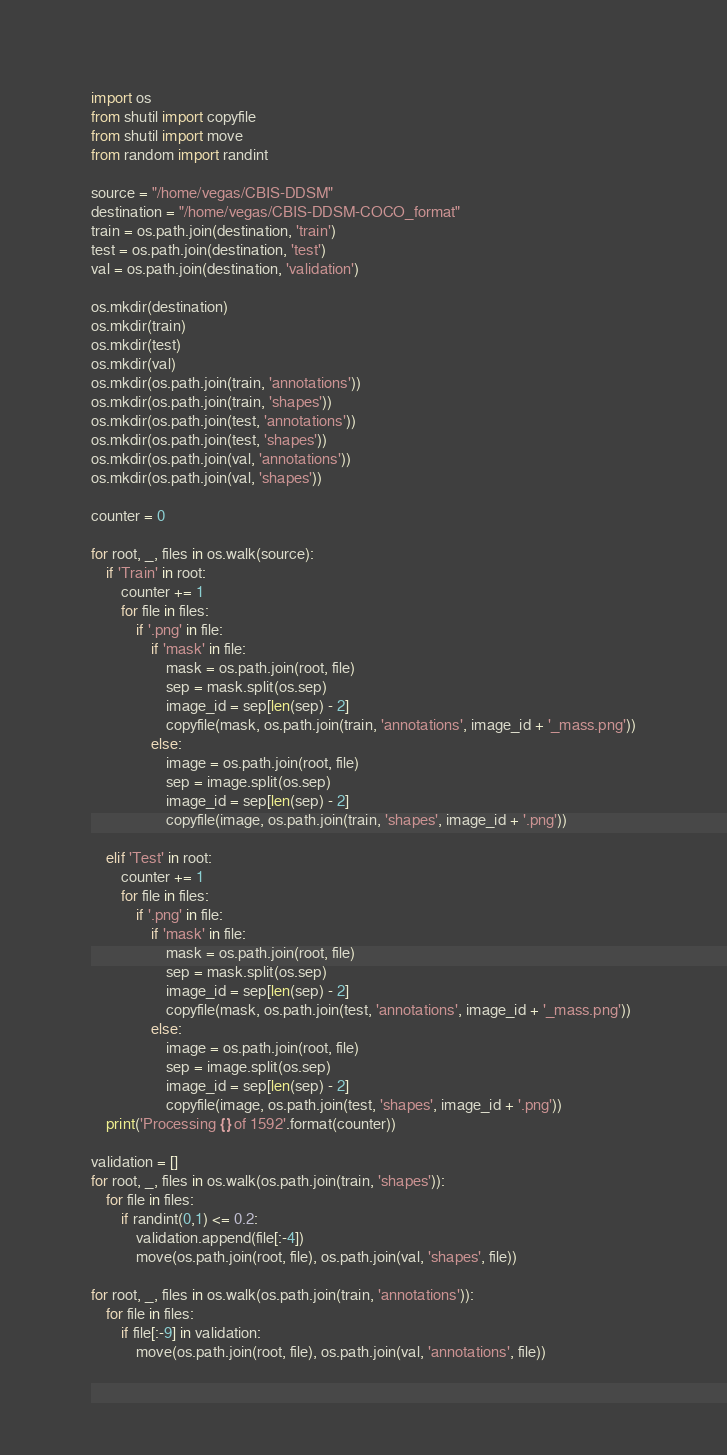<code> <loc_0><loc_0><loc_500><loc_500><_Python_>import os
from shutil import copyfile
from shutil import move
from random import randint

source = "/home/vegas/CBIS-DDSM"
destination = "/home/vegas/CBIS-DDSM-COCO_format"
train = os.path.join(destination, 'train')
test = os.path.join(destination, 'test')
val = os.path.join(destination, 'validation')

os.mkdir(destination)
os.mkdir(train)
os.mkdir(test)
os.mkdir(val)
os.mkdir(os.path.join(train, 'annotations'))
os.mkdir(os.path.join(train, 'shapes'))
os.mkdir(os.path.join(test, 'annotations'))
os.mkdir(os.path.join(test, 'shapes'))
os.mkdir(os.path.join(val, 'annotations'))
os.mkdir(os.path.join(val, 'shapes'))

counter = 0

for root, _, files in os.walk(source):
    if 'Train' in root:
        counter += 1
        for file in files:
            if '.png' in file:
                if 'mask' in file:
                    mask = os.path.join(root, file)
                    sep = mask.split(os.sep)
                    image_id = sep[len(sep) - 2]
                    copyfile(mask, os.path.join(train, 'annotations', image_id + '_mass.png'))
                else:
                    image = os.path.join(root, file)
                    sep = image.split(os.sep)
                    image_id = sep[len(sep) - 2]
                    copyfile(image, os.path.join(train, 'shapes', image_id + '.png'))

    elif 'Test' in root:
        counter += 1
        for file in files:
            if '.png' in file:
                if 'mask' in file:
                    mask = os.path.join(root, file)
                    sep = mask.split(os.sep)
                    image_id = sep[len(sep) - 2]
                    copyfile(mask, os.path.join(test, 'annotations', image_id + '_mass.png'))
                else:
                    image = os.path.join(root, file)
                    sep = image.split(os.sep)
                    image_id = sep[len(sep) - 2]
                    copyfile(image, os.path.join(test, 'shapes', image_id + '.png'))
    print('Processing {} of 1592'.format(counter))

validation = []
for root, _, files in os.walk(os.path.join(train, 'shapes')):
    for file in files:
        if randint(0,1) <= 0.2:
            validation.append(file[:-4])
            move(os.path.join(root, file), os.path.join(val, 'shapes', file))

for root, _, files in os.walk(os.path.join(train, 'annotations')):
    for file in files:
        if file[:-9] in validation:
            move(os.path.join(root, file), os.path.join(val, 'annotations', file))

</code> 